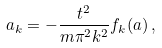<formula> <loc_0><loc_0><loc_500><loc_500>a _ { k } = - \frac { t ^ { 2 } } { m \pi ^ { 2 } k ^ { 2 } } f _ { k } ( { a } ) \, ,</formula> 